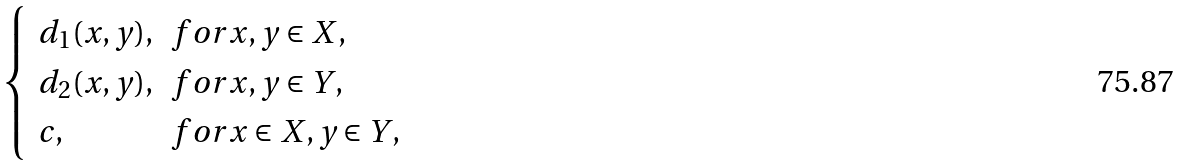<formula> <loc_0><loc_0><loc_500><loc_500>\begin{cases} \begin{array} { l l } d _ { 1 } ( x , y ) , & f o r x , y \in X , \\ d _ { 2 } ( x , y ) , & f o r x , y \in Y , \\ c , & f o r x \in X , y \in Y , \end{array} \end{cases}</formula> 